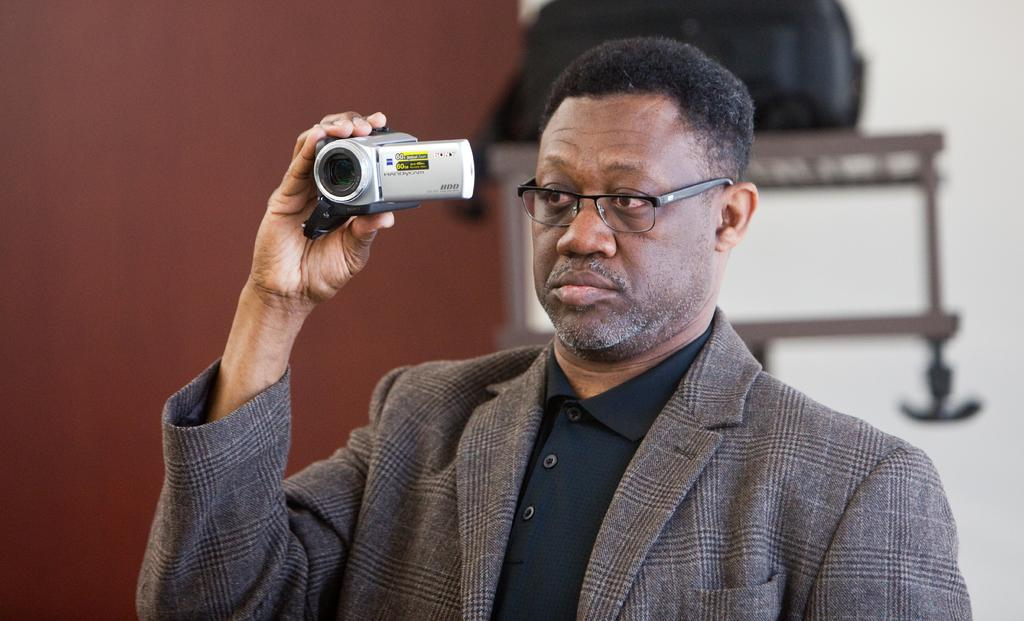Who is present in the image? A: There is a person in the image. What is the person holding? The person is holding a camera. Can you describe the background of the image? The background of the image is blurry, and there are walls visible. What other objects can be seen in the background? There is a bag and a table in the background. What street is the person standing on in the image? There is no street visible in the image; it only shows a person holding a camera and a blurry background with walls, a bag, and a table. 